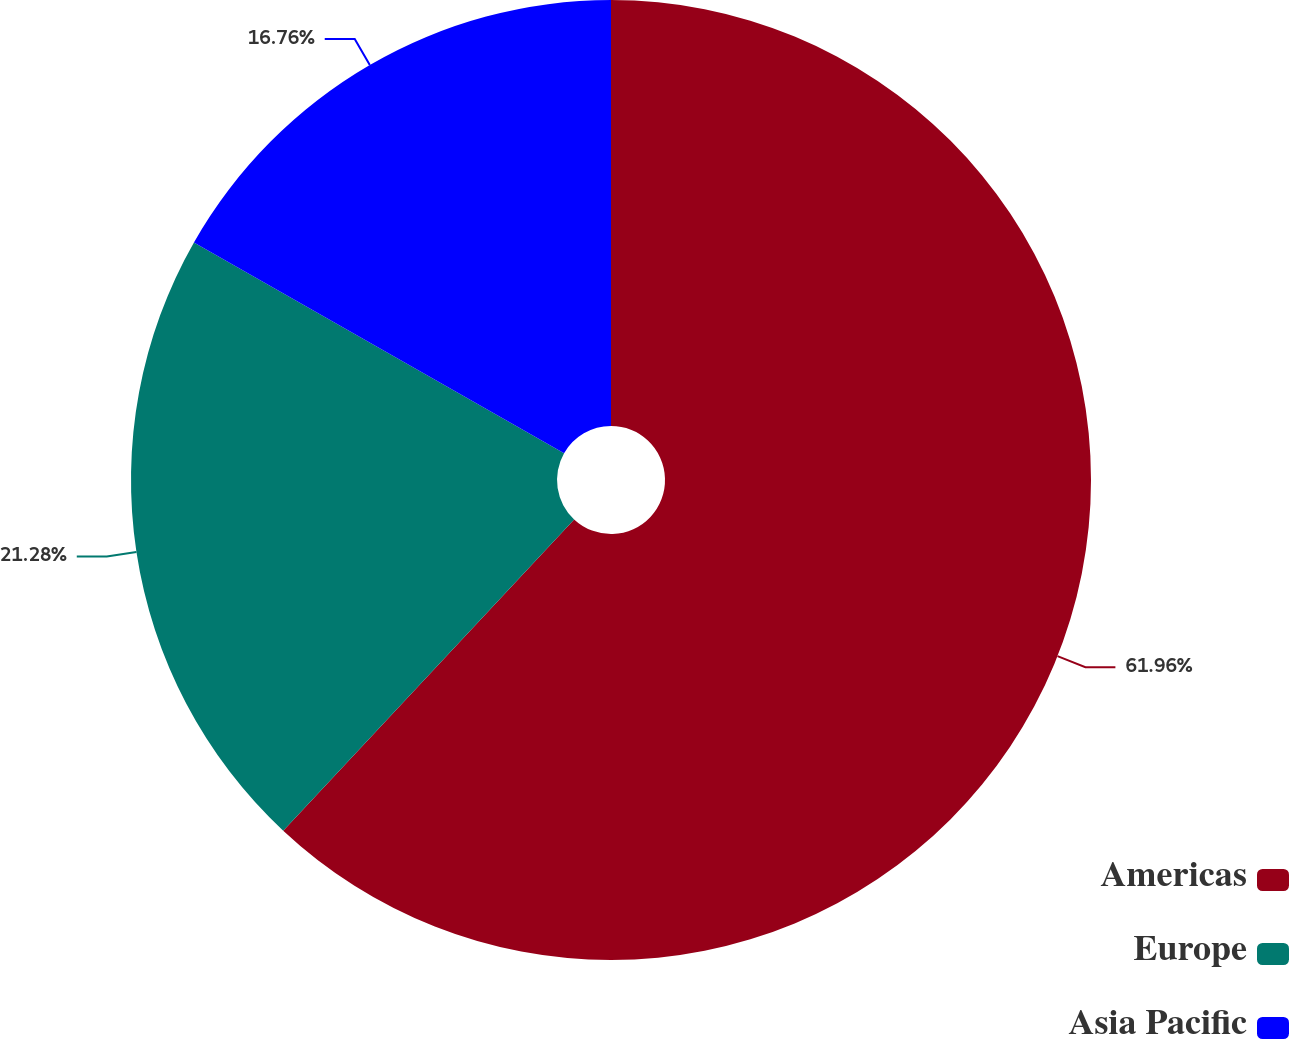<chart> <loc_0><loc_0><loc_500><loc_500><pie_chart><fcel>Americas<fcel>Europe<fcel>Asia Pacific<nl><fcel>61.97%<fcel>21.28%<fcel>16.76%<nl></chart> 